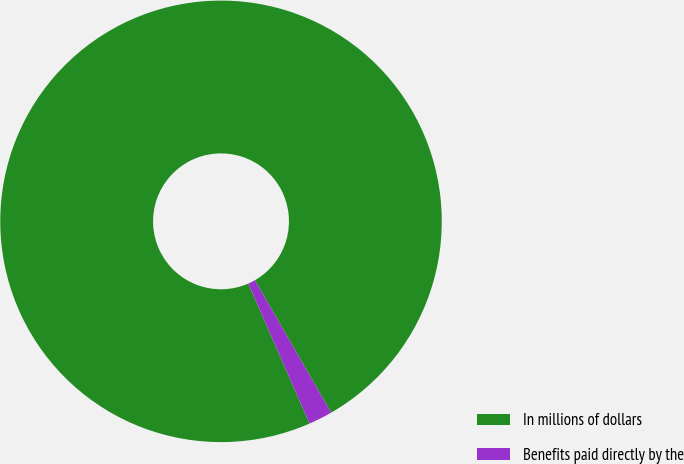Convert chart to OTSL. <chart><loc_0><loc_0><loc_500><loc_500><pie_chart><fcel>In millions of dollars<fcel>Benefits paid directly by the<nl><fcel>98.25%<fcel>1.75%<nl></chart> 